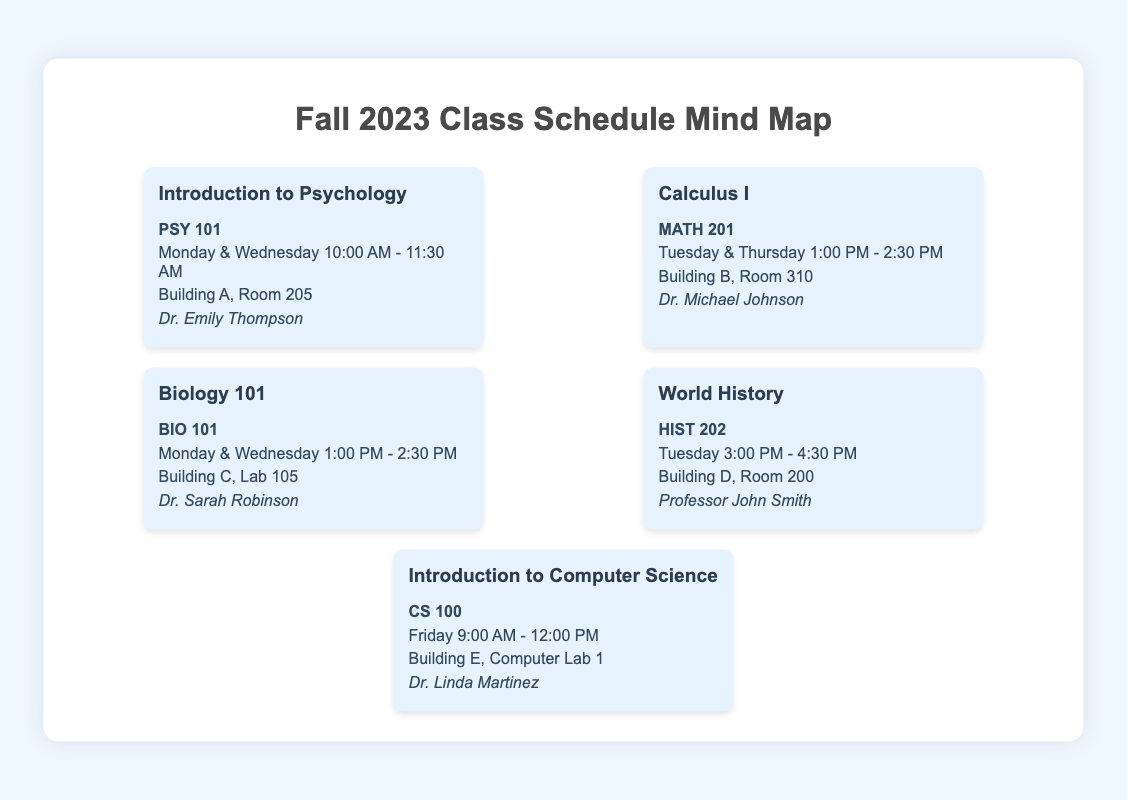What is the title of the document? The title of the document is stated at the top, highlighting the session and topic.
Answer: Fall 2023 Class Schedule Mind Map Who is the professor for Calculus I? The professor's name is mentioned alongside the course information.
Answer: Dr. Michael Johnson What room is Biology 101 held in? The location is specified under the class schedule details for Biology 101.
Answer: Building C, Lab 105 What days are Introduction to Psychology classes scheduled? The days are clearly listed in the class schedule for Introduction to Psychology.
Answer: Monday & Wednesday Which course has the earliest start time on Friday? The start time is mentioned next to the course details, allowing comparison across classes.
Answer: Introduction to Computer Science How many courses are scheduled on Tuesday? The document lists the courses under the schedule, where the days can be counted directly.
Answer: 2 What is the time frame for World History classes? The specific class time is stated in the course description for World History.
Answer: 3:00 PM - 4:30 PM Which building hosts the Introduction to Computer Science class? The class location is indicated in the details of the course.
Answer: Building E Who teaches Biology 101? The professor's name is provided in the course details section for Biology 101.
Answer: Dr. Sarah Robinson 